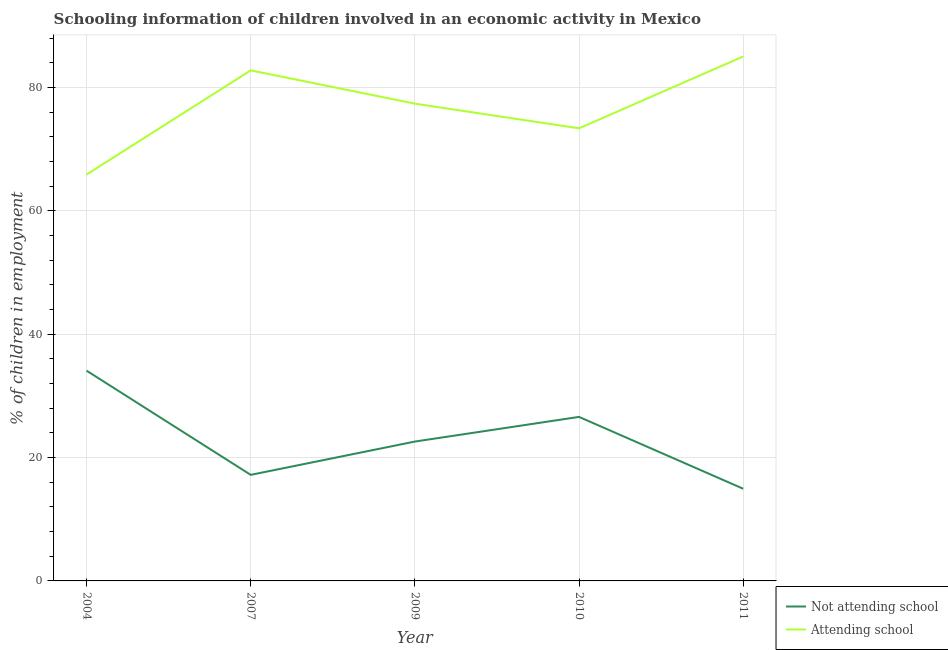Does the line corresponding to percentage of employed children who are attending school intersect with the line corresponding to percentage of employed children who are not attending school?
Keep it short and to the point. No. Across all years, what is the maximum percentage of employed children who are attending school?
Offer a terse response. 85.05. Across all years, what is the minimum percentage of employed children who are not attending school?
Offer a terse response. 14.95. In which year was the percentage of employed children who are not attending school maximum?
Make the answer very short. 2004. In which year was the percentage of employed children who are attending school minimum?
Ensure brevity in your answer.  2004. What is the total percentage of employed children who are not attending school in the graph?
Your response must be concise. 115.45. What is the difference between the percentage of employed children who are attending school in 2007 and that in 2010?
Your response must be concise. 9.4. What is the difference between the percentage of employed children who are not attending school in 2011 and the percentage of employed children who are attending school in 2009?
Provide a succinct answer. -62.45. What is the average percentage of employed children who are not attending school per year?
Keep it short and to the point. 23.09. In the year 2010, what is the difference between the percentage of employed children who are not attending school and percentage of employed children who are attending school?
Offer a very short reply. -46.8. What is the ratio of the percentage of employed children who are not attending school in 2007 to that in 2010?
Your answer should be compact. 0.65. Is the percentage of employed children who are not attending school in 2007 less than that in 2011?
Keep it short and to the point. No. Is the difference between the percentage of employed children who are attending school in 2010 and 2011 greater than the difference between the percentage of employed children who are not attending school in 2010 and 2011?
Keep it short and to the point. No. What is the difference between the highest and the second highest percentage of employed children who are attending school?
Your answer should be very brief. 2.25. What is the difference between the highest and the lowest percentage of employed children who are attending school?
Provide a short and direct response. 19.15. In how many years, is the percentage of employed children who are attending school greater than the average percentage of employed children who are attending school taken over all years?
Give a very brief answer. 3. Is the sum of the percentage of employed children who are attending school in 2004 and 2009 greater than the maximum percentage of employed children who are not attending school across all years?
Offer a terse response. Yes. Is the percentage of employed children who are not attending school strictly greater than the percentage of employed children who are attending school over the years?
Make the answer very short. No. Is the percentage of employed children who are not attending school strictly less than the percentage of employed children who are attending school over the years?
Ensure brevity in your answer.  Yes. How many years are there in the graph?
Your answer should be compact. 5. Does the graph contain grids?
Offer a terse response. Yes. Where does the legend appear in the graph?
Keep it short and to the point. Bottom right. How are the legend labels stacked?
Provide a short and direct response. Vertical. What is the title of the graph?
Give a very brief answer. Schooling information of children involved in an economic activity in Mexico. What is the label or title of the Y-axis?
Your answer should be compact. % of children in employment. What is the % of children in employment in Not attending school in 2004?
Offer a very short reply. 34.1. What is the % of children in employment of Attending school in 2004?
Provide a succinct answer. 65.9. What is the % of children in employment in Not attending school in 2007?
Offer a very short reply. 17.2. What is the % of children in employment of Attending school in 2007?
Ensure brevity in your answer.  82.8. What is the % of children in employment of Not attending school in 2009?
Ensure brevity in your answer.  22.6. What is the % of children in employment of Attending school in 2009?
Offer a very short reply. 77.4. What is the % of children in employment in Not attending school in 2010?
Offer a very short reply. 26.6. What is the % of children in employment of Attending school in 2010?
Provide a succinct answer. 73.4. What is the % of children in employment of Not attending school in 2011?
Offer a terse response. 14.95. What is the % of children in employment of Attending school in 2011?
Give a very brief answer. 85.05. Across all years, what is the maximum % of children in employment in Not attending school?
Keep it short and to the point. 34.1. Across all years, what is the maximum % of children in employment of Attending school?
Keep it short and to the point. 85.05. Across all years, what is the minimum % of children in employment in Not attending school?
Your response must be concise. 14.95. Across all years, what is the minimum % of children in employment in Attending school?
Offer a terse response. 65.9. What is the total % of children in employment of Not attending school in the graph?
Ensure brevity in your answer.  115.45. What is the total % of children in employment of Attending school in the graph?
Provide a succinct answer. 384.55. What is the difference between the % of children in employment in Attending school in 2004 and that in 2007?
Offer a very short reply. -16.9. What is the difference between the % of children in employment of Not attending school in 2004 and that in 2009?
Keep it short and to the point. 11.5. What is the difference between the % of children in employment in Not attending school in 2004 and that in 2010?
Keep it short and to the point. 7.5. What is the difference between the % of children in employment in Attending school in 2004 and that in 2010?
Your answer should be compact. -7.5. What is the difference between the % of children in employment of Not attending school in 2004 and that in 2011?
Your response must be concise. 19.15. What is the difference between the % of children in employment in Attending school in 2004 and that in 2011?
Ensure brevity in your answer.  -19.15. What is the difference between the % of children in employment of Not attending school in 2007 and that in 2009?
Ensure brevity in your answer.  -5.4. What is the difference between the % of children in employment in Attending school in 2007 and that in 2009?
Offer a very short reply. 5.4. What is the difference between the % of children in employment of Attending school in 2007 and that in 2010?
Give a very brief answer. 9.4. What is the difference between the % of children in employment in Not attending school in 2007 and that in 2011?
Keep it short and to the point. 2.25. What is the difference between the % of children in employment of Attending school in 2007 and that in 2011?
Offer a terse response. -2.25. What is the difference between the % of children in employment in Not attending school in 2009 and that in 2010?
Ensure brevity in your answer.  -4. What is the difference between the % of children in employment of Not attending school in 2009 and that in 2011?
Keep it short and to the point. 7.65. What is the difference between the % of children in employment in Attending school in 2009 and that in 2011?
Offer a terse response. -7.65. What is the difference between the % of children in employment of Not attending school in 2010 and that in 2011?
Give a very brief answer. 11.65. What is the difference between the % of children in employment in Attending school in 2010 and that in 2011?
Your answer should be very brief. -11.65. What is the difference between the % of children in employment in Not attending school in 2004 and the % of children in employment in Attending school in 2007?
Your answer should be very brief. -48.7. What is the difference between the % of children in employment of Not attending school in 2004 and the % of children in employment of Attending school in 2009?
Provide a succinct answer. -43.3. What is the difference between the % of children in employment of Not attending school in 2004 and the % of children in employment of Attending school in 2010?
Provide a succinct answer. -39.3. What is the difference between the % of children in employment in Not attending school in 2004 and the % of children in employment in Attending school in 2011?
Provide a succinct answer. -50.95. What is the difference between the % of children in employment of Not attending school in 2007 and the % of children in employment of Attending school in 2009?
Your response must be concise. -60.2. What is the difference between the % of children in employment of Not attending school in 2007 and the % of children in employment of Attending school in 2010?
Keep it short and to the point. -56.2. What is the difference between the % of children in employment of Not attending school in 2007 and the % of children in employment of Attending school in 2011?
Make the answer very short. -67.85. What is the difference between the % of children in employment of Not attending school in 2009 and the % of children in employment of Attending school in 2010?
Provide a short and direct response. -50.8. What is the difference between the % of children in employment of Not attending school in 2009 and the % of children in employment of Attending school in 2011?
Provide a succinct answer. -62.45. What is the difference between the % of children in employment in Not attending school in 2010 and the % of children in employment in Attending school in 2011?
Make the answer very short. -58.45. What is the average % of children in employment in Not attending school per year?
Provide a succinct answer. 23.09. What is the average % of children in employment in Attending school per year?
Offer a terse response. 76.91. In the year 2004, what is the difference between the % of children in employment in Not attending school and % of children in employment in Attending school?
Provide a short and direct response. -31.8. In the year 2007, what is the difference between the % of children in employment of Not attending school and % of children in employment of Attending school?
Keep it short and to the point. -65.6. In the year 2009, what is the difference between the % of children in employment in Not attending school and % of children in employment in Attending school?
Your answer should be very brief. -54.8. In the year 2010, what is the difference between the % of children in employment of Not attending school and % of children in employment of Attending school?
Ensure brevity in your answer.  -46.8. In the year 2011, what is the difference between the % of children in employment in Not attending school and % of children in employment in Attending school?
Offer a terse response. -70.1. What is the ratio of the % of children in employment in Not attending school in 2004 to that in 2007?
Give a very brief answer. 1.98. What is the ratio of the % of children in employment of Attending school in 2004 to that in 2007?
Keep it short and to the point. 0.8. What is the ratio of the % of children in employment of Not attending school in 2004 to that in 2009?
Provide a succinct answer. 1.51. What is the ratio of the % of children in employment in Attending school in 2004 to that in 2009?
Ensure brevity in your answer.  0.85. What is the ratio of the % of children in employment in Not attending school in 2004 to that in 2010?
Make the answer very short. 1.28. What is the ratio of the % of children in employment in Attending school in 2004 to that in 2010?
Offer a very short reply. 0.9. What is the ratio of the % of children in employment of Not attending school in 2004 to that in 2011?
Provide a short and direct response. 2.28. What is the ratio of the % of children in employment of Attending school in 2004 to that in 2011?
Your response must be concise. 0.77. What is the ratio of the % of children in employment in Not attending school in 2007 to that in 2009?
Ensure brevity in your answer.  0.76. What is the ratio of the % of children in employment of Attending school in 2007 to that in 2009?
Provide a succinct answer. 1.07. What is the ratio of the % of children in employment of Not attending school in 2007 to that in 2010?
Offer a terse response. 0.65. What is the ratio of the % of children in employment in Attending school in 2007 to that in 2010?
Provide a short and direct response. 1.13. What is the ratio of the % of children in employment of Not attending school in 2007 to that in 2011?
Your answer should be very brief. 1.15. What is the ratio of the % of children in employment in Attending school in 2007 to that in 2011?
Your answer should be compact. 0.97. What is the ratio of the % of children in employment of Not attending school in 2009 to that in 2010?
Make the answer very short. 0.85. What is the ratio of the % of children in employment of Attending school in 2009 to that in 2010?
Give a very brief answer. 1.05. What is the ratio of the % of children in employment of Not attending school in 2009 to that in 2011?
Offer a very short reply. 1.51. What is the ratio of the % of children in employment of Attending school in 2009 to that in 2011?
Give a very brief answer. 0.91. What is the ratio of the % of children in employment of Not attending school in 2010 to that in 2011?
Provide a succinct answer. 1.78. What is the ratio of the % of children in employment in Attending school in 2010 to that in 2011?
Keep it short and to the point. 0.86. What is the difference between the highest and the second highest % of children in employment in Not attending school?
Offer a very short reply. 7.5. What is the difference between the highest and the second highest % of children in employment in Attending school?
Make the answer very short. 2.25. What is the difference between the highest and the lowest % of children in employment of Not attending school?
Give a very brief answer. 19.15. What is the difference between the highest and the lowest % of children in employment in Attending school?
Give a very brief answer. 19.15. 